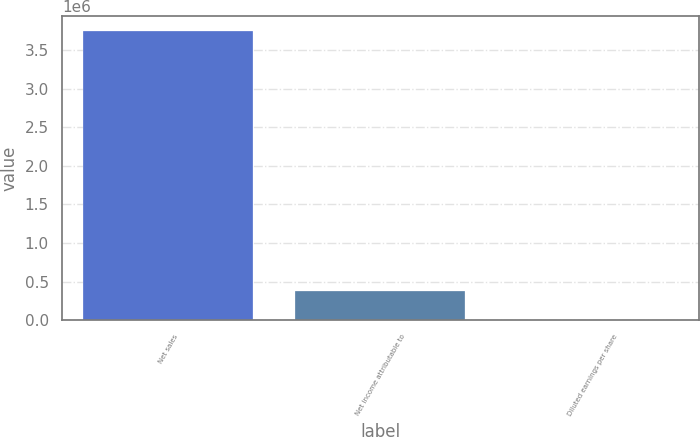<chart> <loc_0><loc_0><loc_500><loc_500><bar_chart><fcel>Net sales<fcel>Net income attributable to<fcel>Diluted earnings per share<nl><fcel>3.74959e+06<fcel>374962<fcel>2.7<nl></chart> 